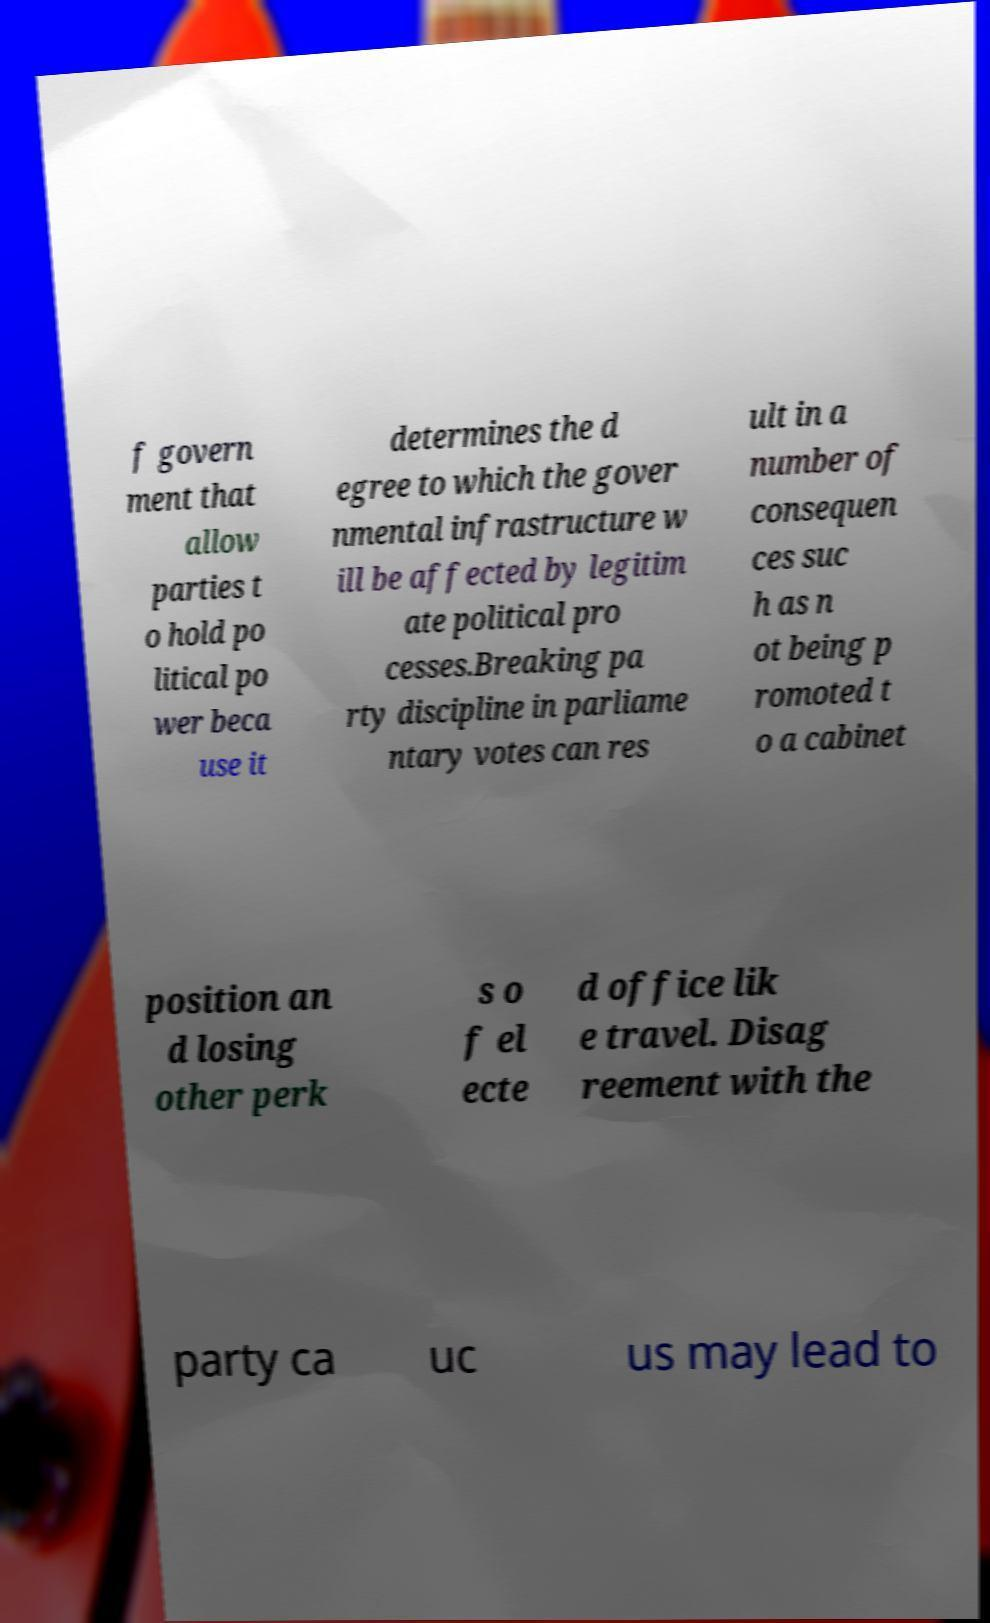There's text embedded in this image that I need extracted. Can you transcribe it verbatim? f govern ment that allow parties t o hold po litical po wer beca use it determines the d egree to which the gover nmental infrastructure w ill be affected by legitim ate political pro cesses.Breaking pa rty discipline in parliame ntary votes can res ult in a number of consequen ces suc h as n ot being p romoted t o a cabinet position an d losing other perk s o f el ecte d office lik e travel. Disag reement with the party ca uc us may lead to 